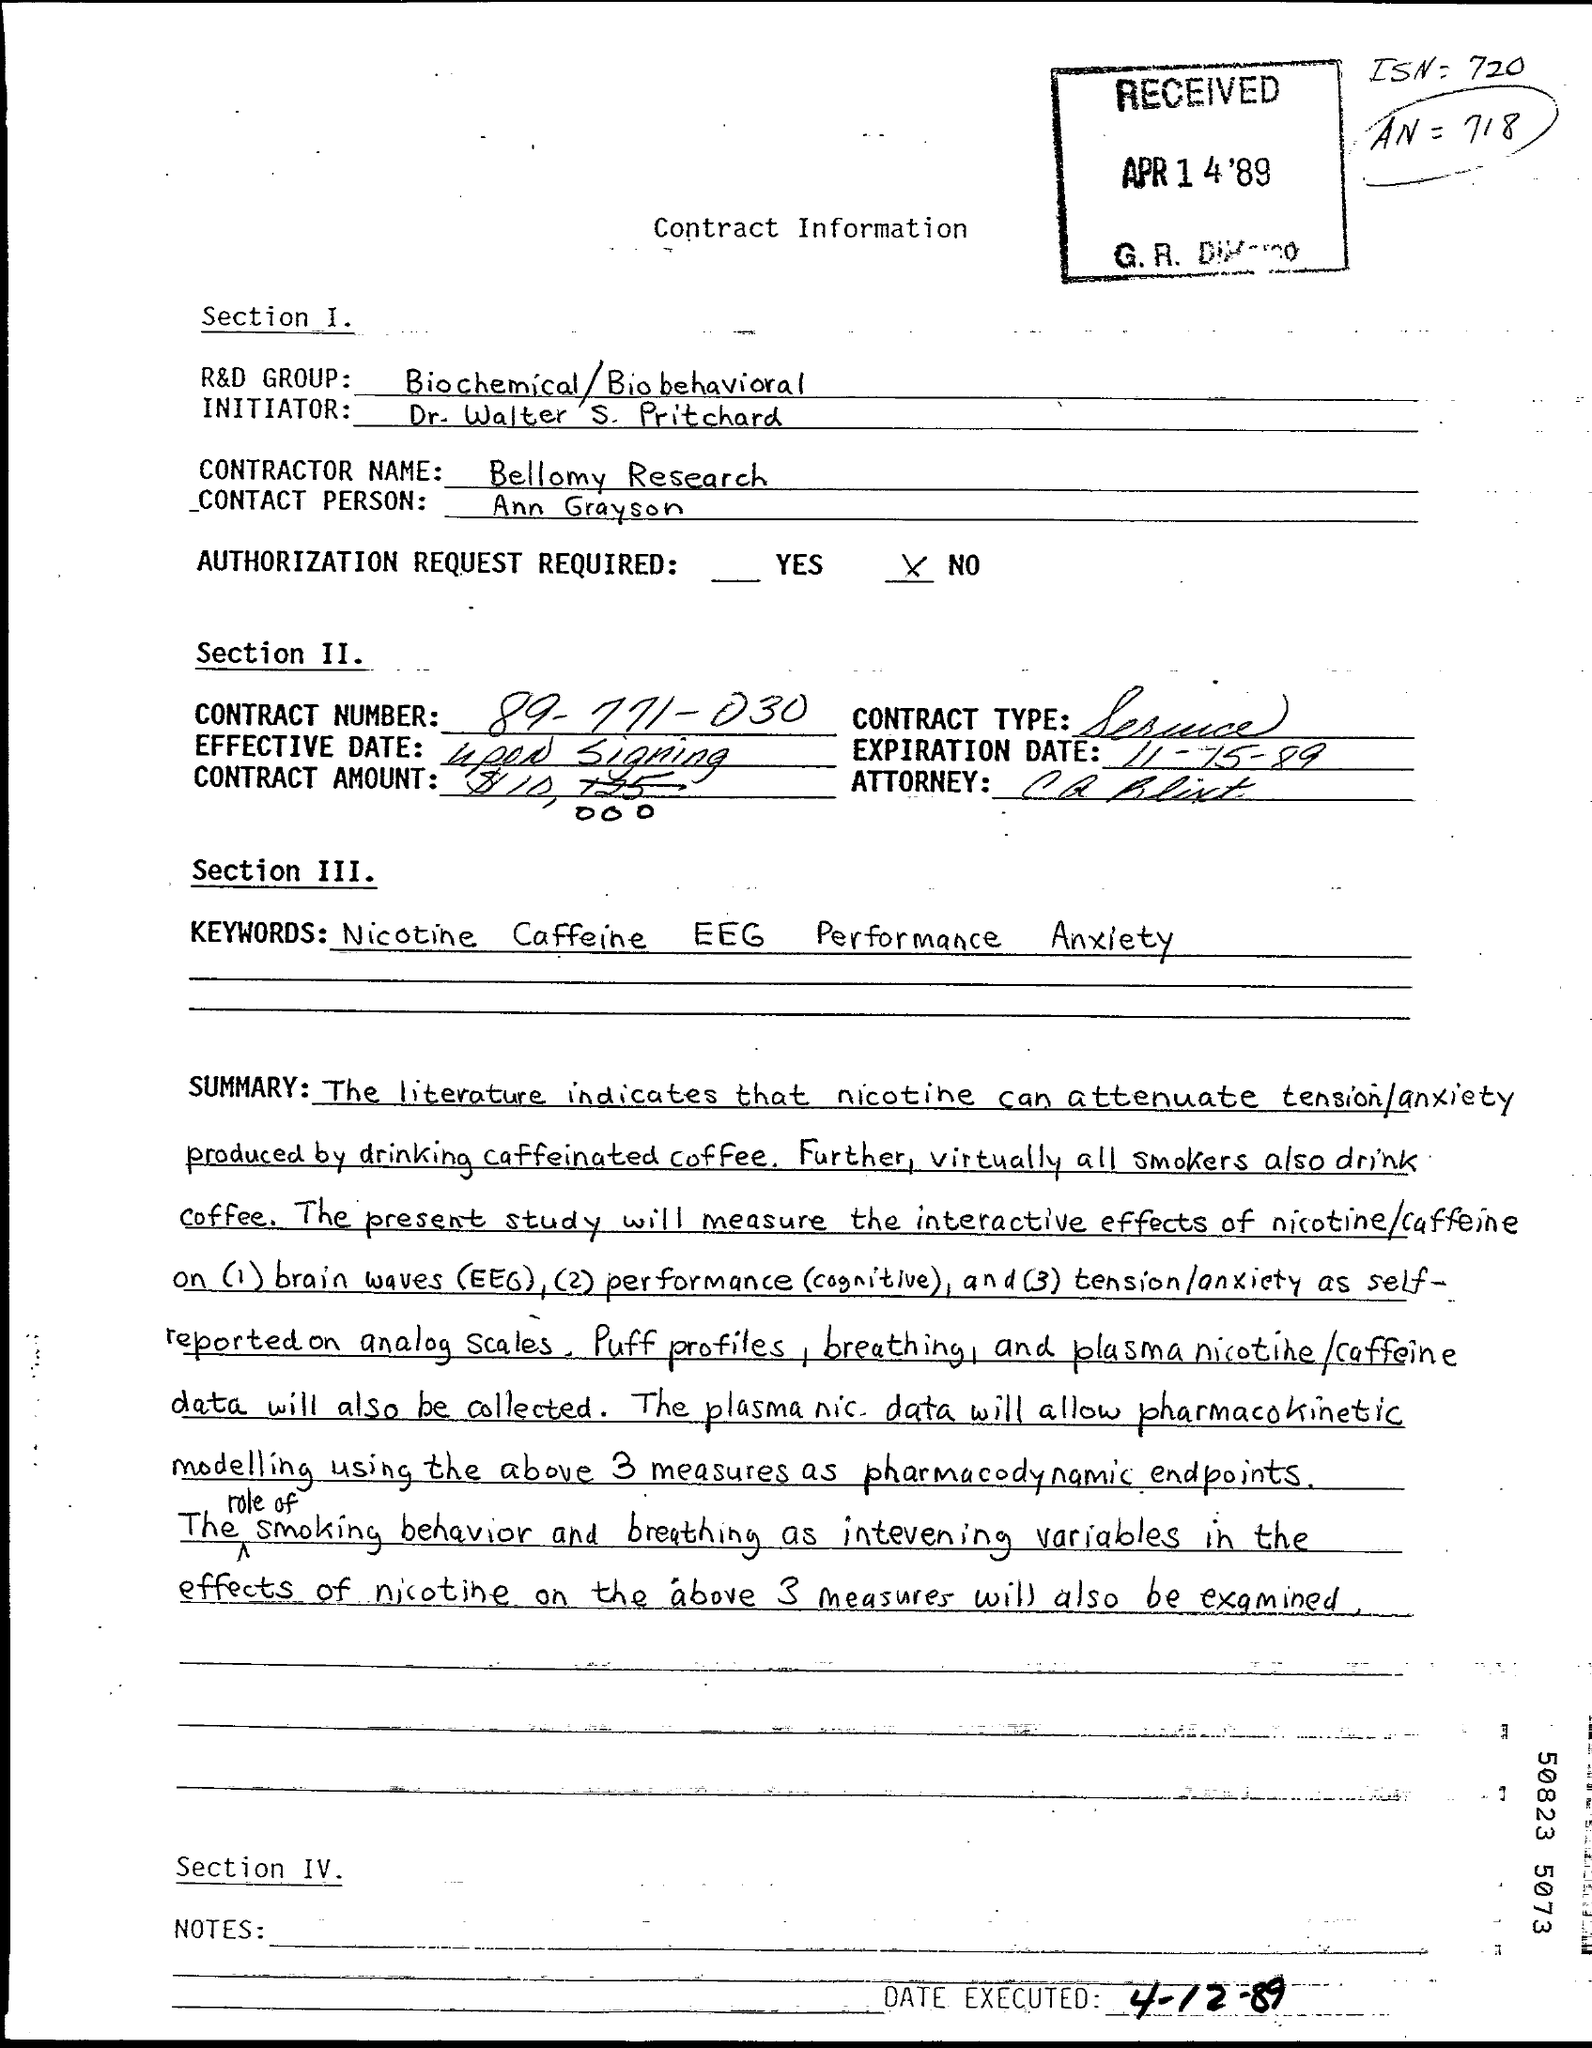Specify some key components in this picture. The Contractor name specified in the document is Bellomy Research. The expiration date mentioned in the document is 11-15-89. Ann Grayson is the contact person as per the document. Dr. Walter S. Pritchard is the initiator of the document, as stated in the text. The Contract Number provided is 89-771-030. 